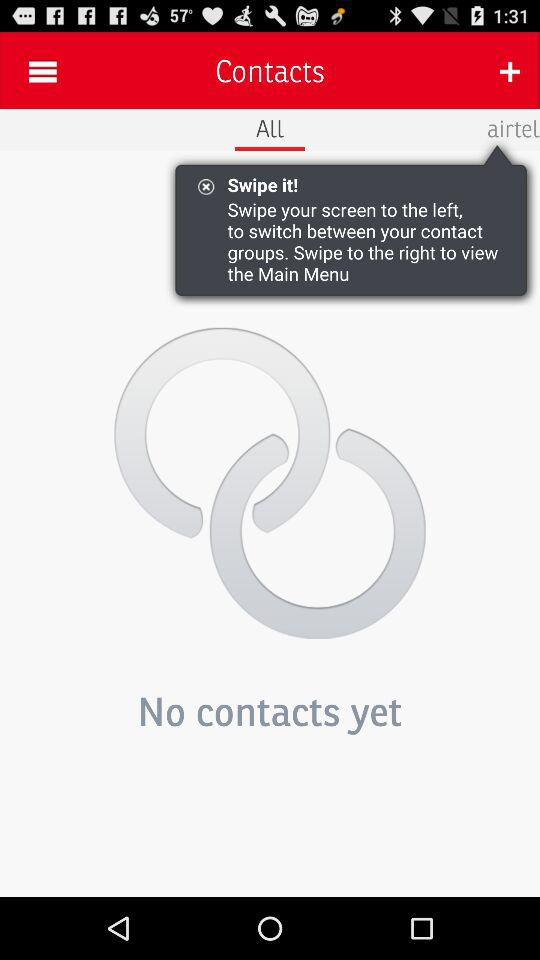What is the application name? The application name is "Contacts". 